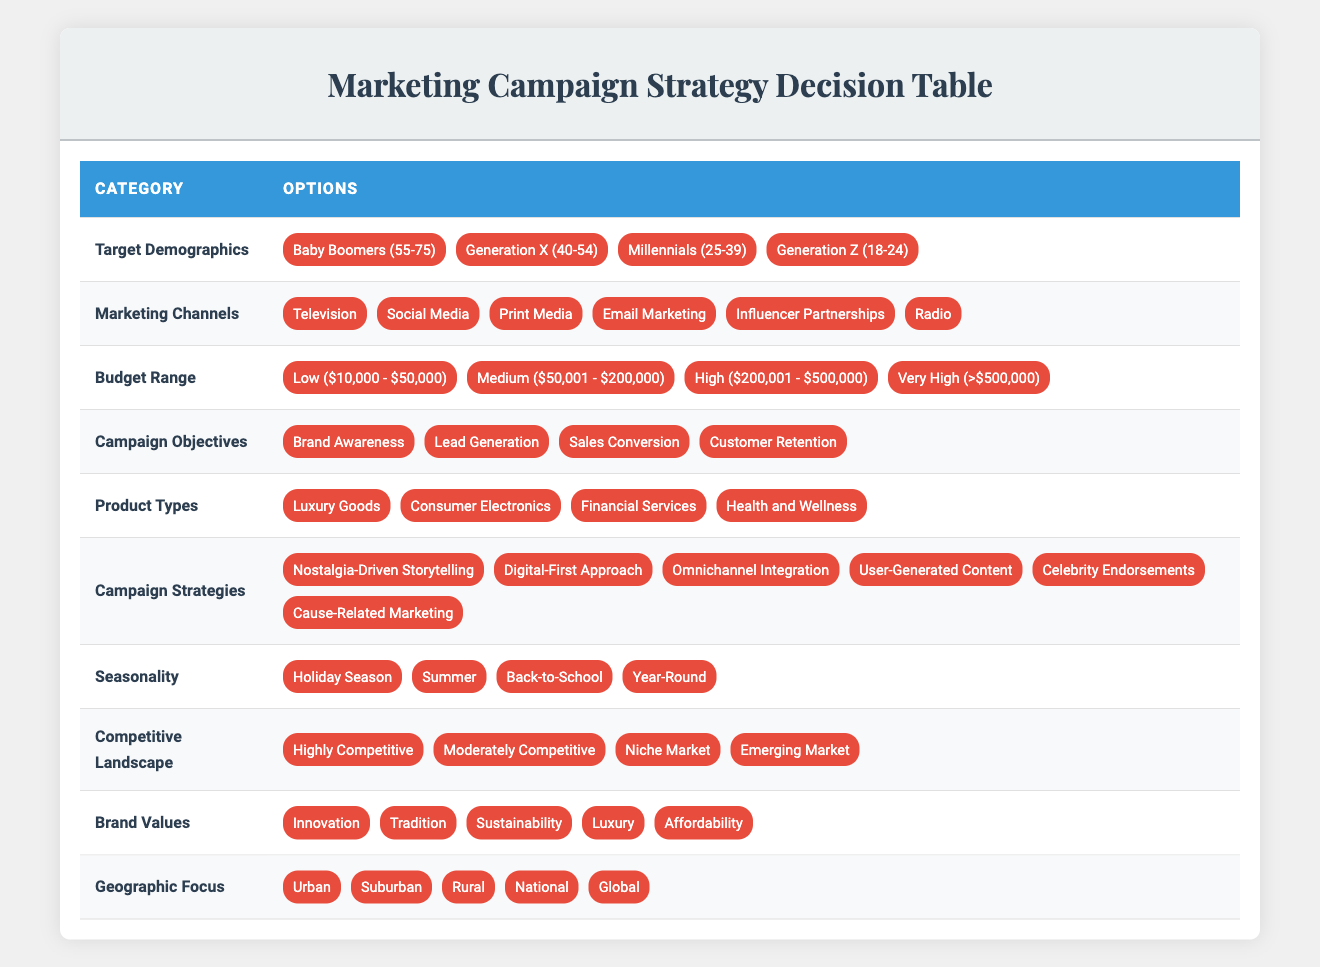What are the target demographics listed in the table? The table includes the target demographics as follows: Baby Boomers (55-75), Generation X (40-54), Millennials (25-39), and Generation Z (18-24).
Answer: Baby Boomers (55-75), Generation X (40-54), Millennials (25-39), Generation Z (18-24) Which marketing channels are suitable for reaching Millennials? The suitable marketing channels for Millennials, based on the table, include Social Media, Email Marketing, and Influencer Partnerships.
Answer: Social Media, Email Marketing, Influencer Partnerships Is "Celebrity Endorsements" listed as one of the campaign strategies? Yes, Celebrity Endorsements is indeed one of the campaign strategies mentioned in the table under Campaign Strategies.
Answer: Yes If a campaign is focused on Brand Awareness and has a Medium budget, what marketing channels would be likely effective? To achieve Brand Awareness with a Medium budget, the effective marketing channels listed include Television, Social Media, and Print Media.
Answer: Television, Social Media, Print Media For Baby Boomers, which campaign strategy would align with their preferences according to traditional values? For Baby Boomers, Nostalgia-Driven Storytelling aligns well with their traditional values, reflecting their historical and nostalgic experiences.
Answer: Nostalgia-Driven Storytelling What is the total number of target demographics and campaign strategies combined? The total number of target demographics is 4 (Baby Boomers, Generation X, Millennials, Generation Z), and the total number of campaign strategies is 6 (Nostalgia-Driven Storytelling, Digital-First Approach, Omnichannel Integration, User-Generated Content, Celebrity Endorsements, Cause-Related Marketing). Thus, the total is 4 + 6 = 10.
Answer: 10 Is there a campaign objective focused on Customer Retention? Yes, Customer Retention is listed as one of the campaign objectives in the table.
Answer: Yes What marketing channels are recommended for a campaign targeted at Generation Z during the Holiday Season? For a campaign focused on Generation Z during the Holiday Season, the recommended marketing channels include Social Media, Influencer Partnerships, and Digital-First approaches to attract and engage this demographic.
Answer: Social Media, Influencer Partnerships Considering a campaign with a Very High budget and targeting Luxury Goods, what campaign strategies are appropriate? For a Very High budget targeting Luxury Goods, appropriate campaign strategies include Celebrity Endorsements and Cause-Related Marketing, as they can leverage high-impact means to engage affluent customers and align with luxury branding.
Answer: Celebrity Endorsements, Cause-Related Marketing 